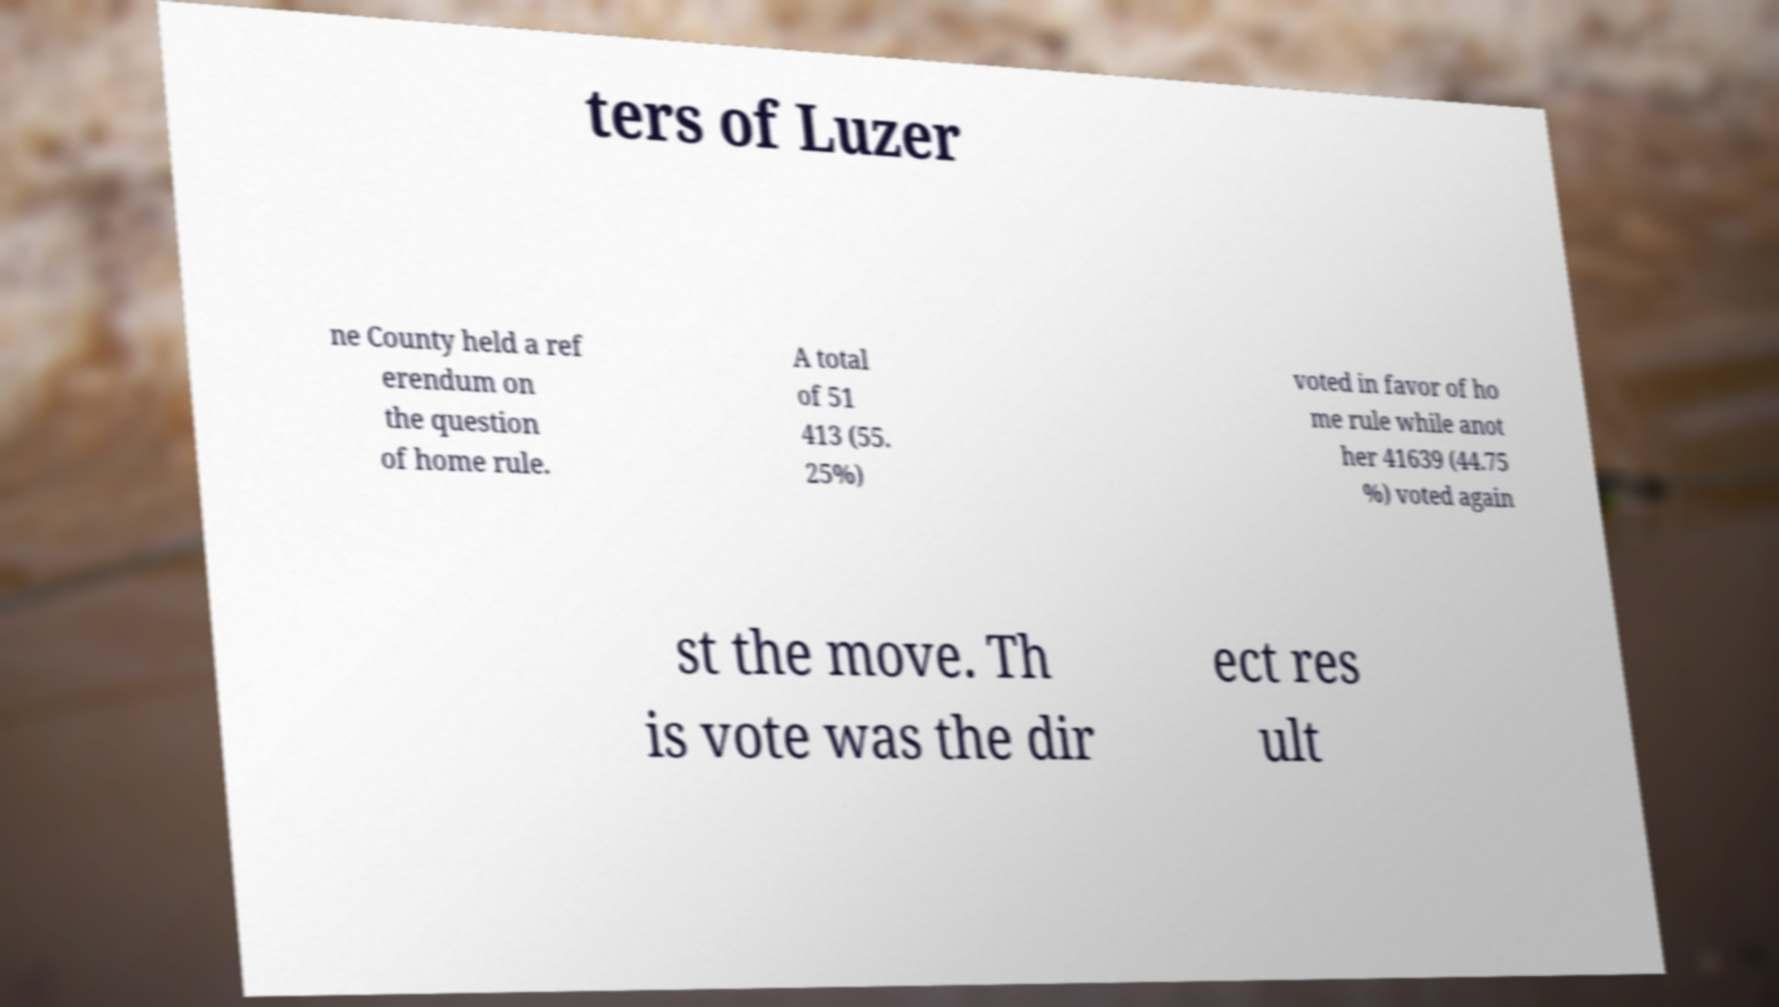What messages or text are displayed in this image? I need them in a readable, typed format. ters of Luzer ne County held a ref erendum on the question of home rule. A total of 51 413 (55. 25%) voted in favor of ho me rule while anot her 41639 (44.75 %) voted again st the move. Th is vote was the dir ect res ult 